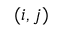Convert formula to latex. <formula><loc_0><loc_0><loc_500><loc_500>( i , j )</formula> 